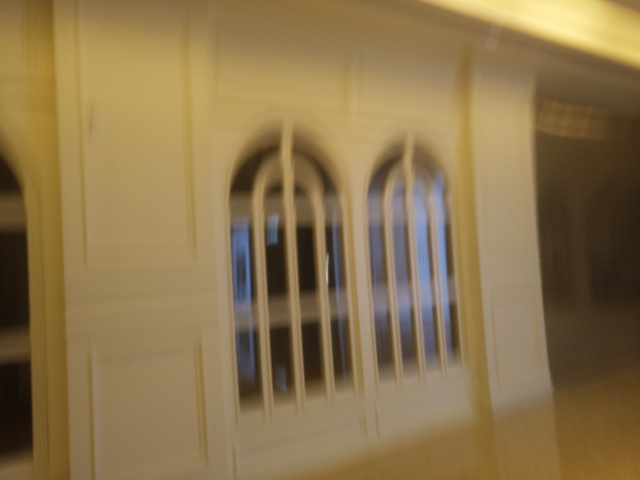What kind of room does this image depict? While it's challenging to ascertain details due to the blurriness, the image seems to depict a room with an elegant architectural style, possibly a hallway or lobby, given the presence of arched windows and what looks like a decorative trim. 